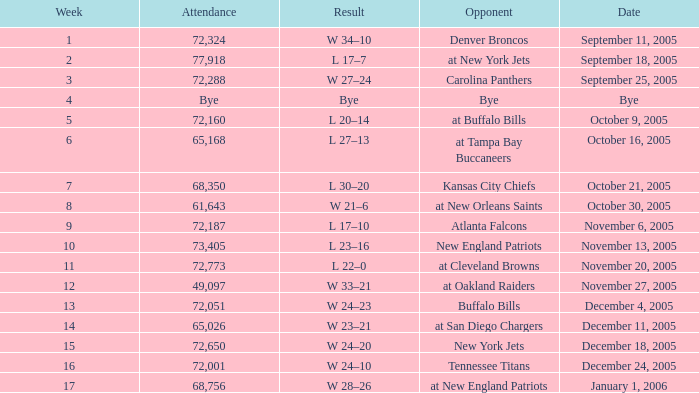What is the Week with a Date of Bye? 1.0. 